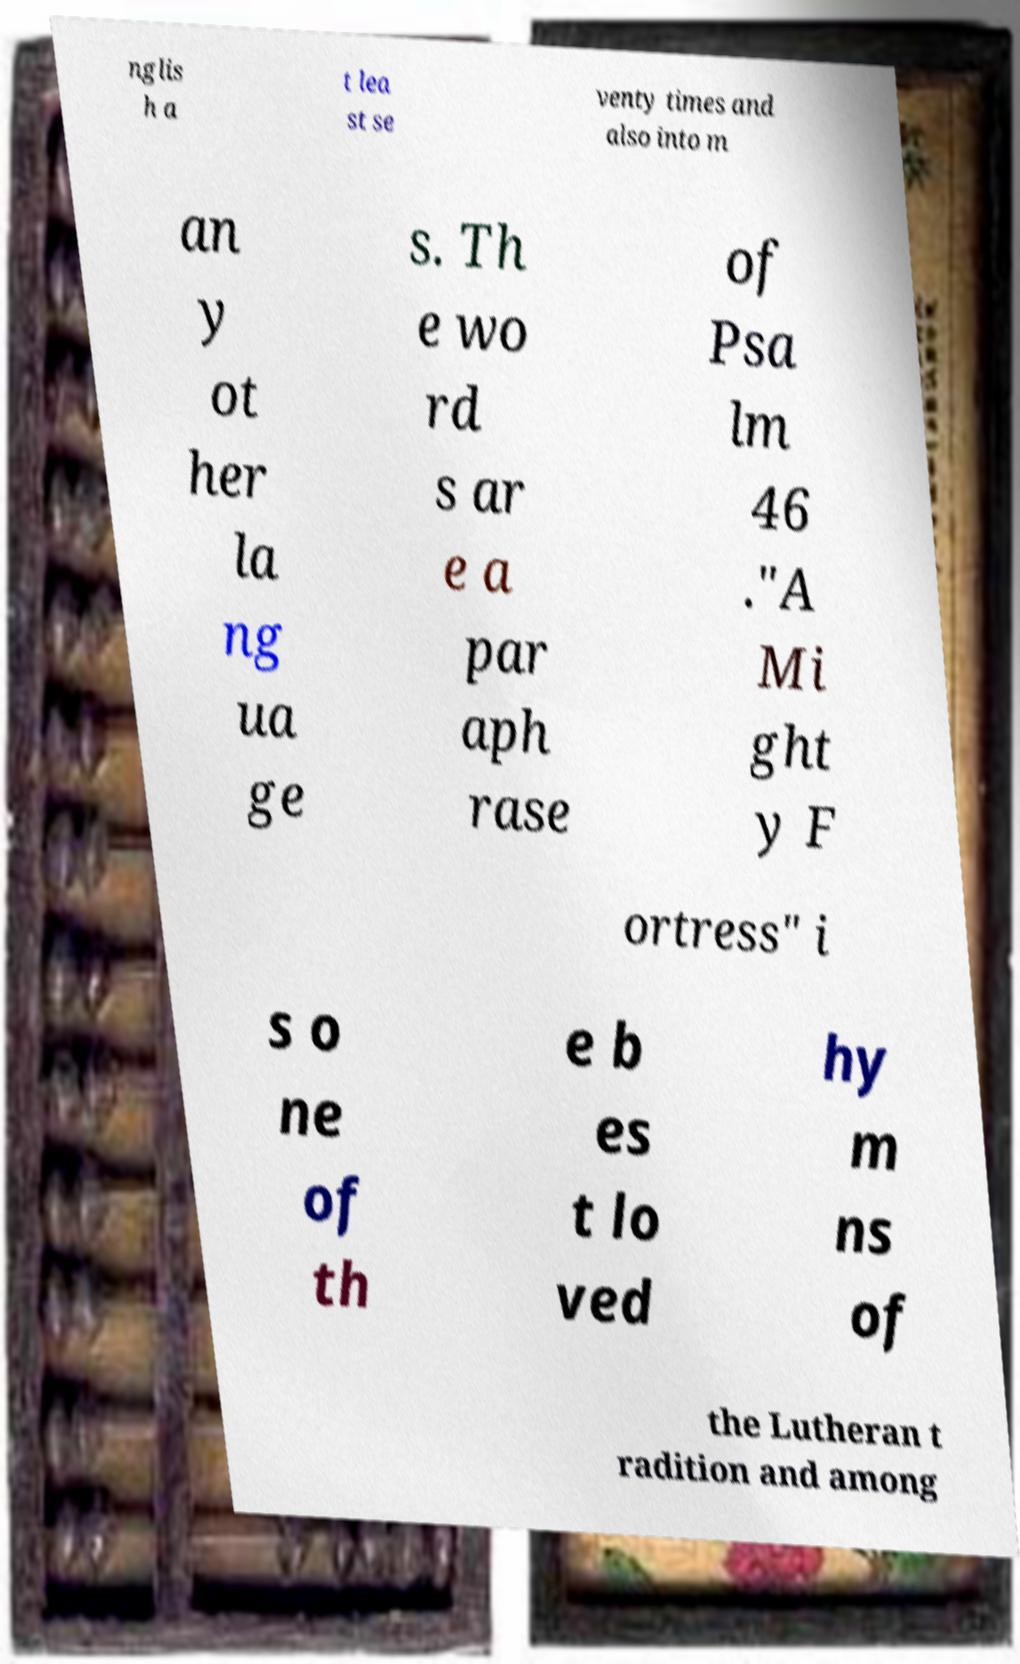Please read and relay the text visible in this image. What does it say? nglis h a t lea st se venty times and also into m an y ot her la ng ua ge s. Th e wo rd s ar e a par aph rase of Psa lm 46 ."A Mi ght y F ortress" i s o ne of th e b es t lo ved hy m ns of the Lutheran t radition and among 